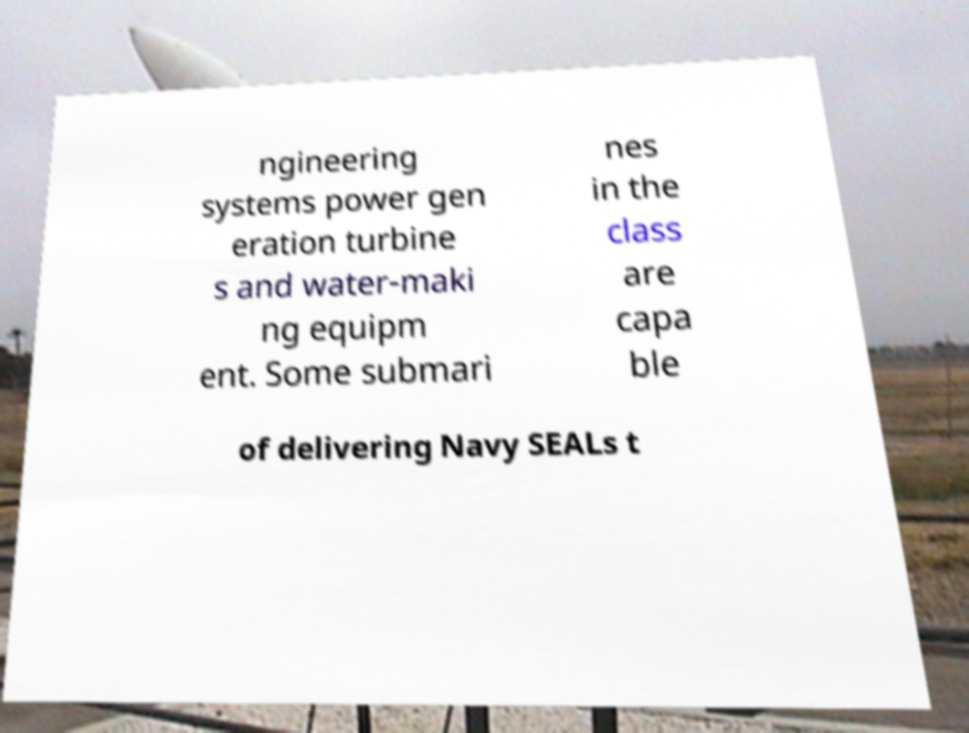Please read and relay the text visible in this image. What does it say? ngineering systems power gen eration turbine s and water-maki ng equipm ent. Some submari nes in the class are capa ble of delivering Navy SEALs t 